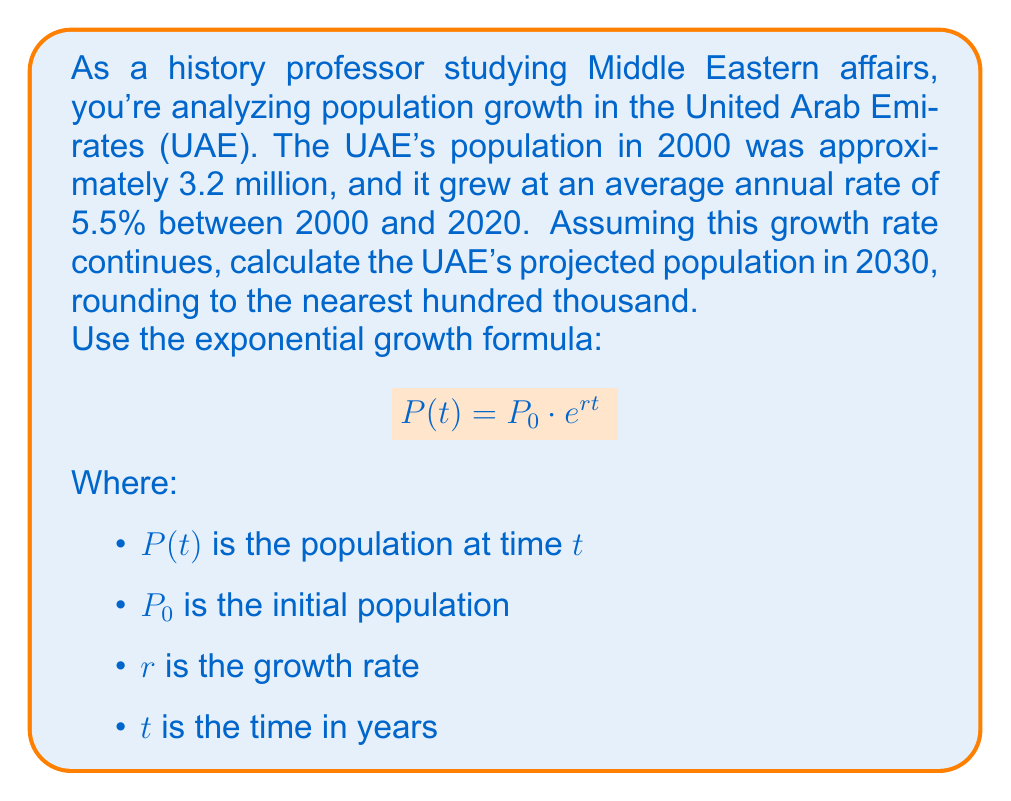Teach me how to tackle this problem. Let's approach this step-by-step:

1) We're given:
   $P_0 = 3.2$ million (population in 2000)
   $r = 5.5\% = 0.055$ per year
   $t = 30$ years (from 2000 to 2030)

2) Plug these values into the exponential growth formula:

   $$P(30) = 3.2 \cdot e^{0.055 \cdot 30}$$

3) Simplify the exponent:
   
   $$P(30) = 3.2 \cdot e^{1.65}$$

4) Calculate $e^{1.65}$ (you can use a calculator for this):
   
   $$P(30) = 3.2 \cdot 5.2070$$

5) Multiply:
   
   $$P(30) = 16.6624$$ million

6) Rounding to the nearest hundred thousand:
   
   $$P(30) \approx 16.7$$ million

Therefore, the projected population of the UAE in 2030 is approximately 16.7 million.
Answer: 16.7 million 